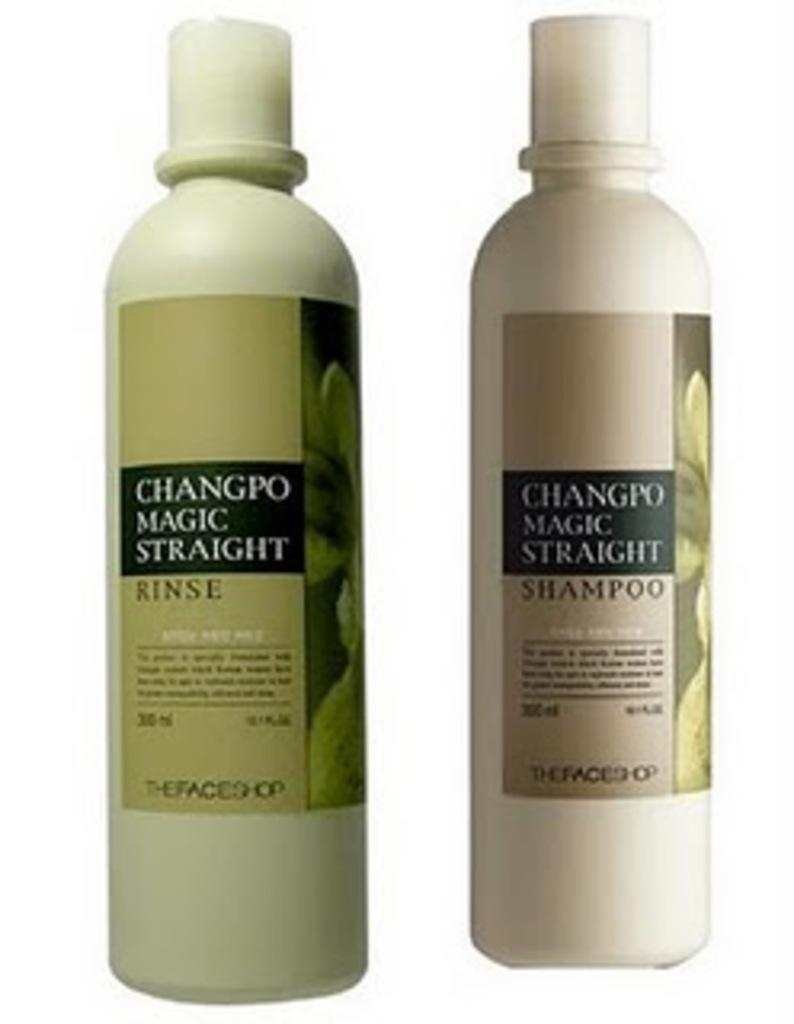<image>
Provide a brief description of the given image. Bottle of Changpo Magic Straight Rinse next to a shampoo. 